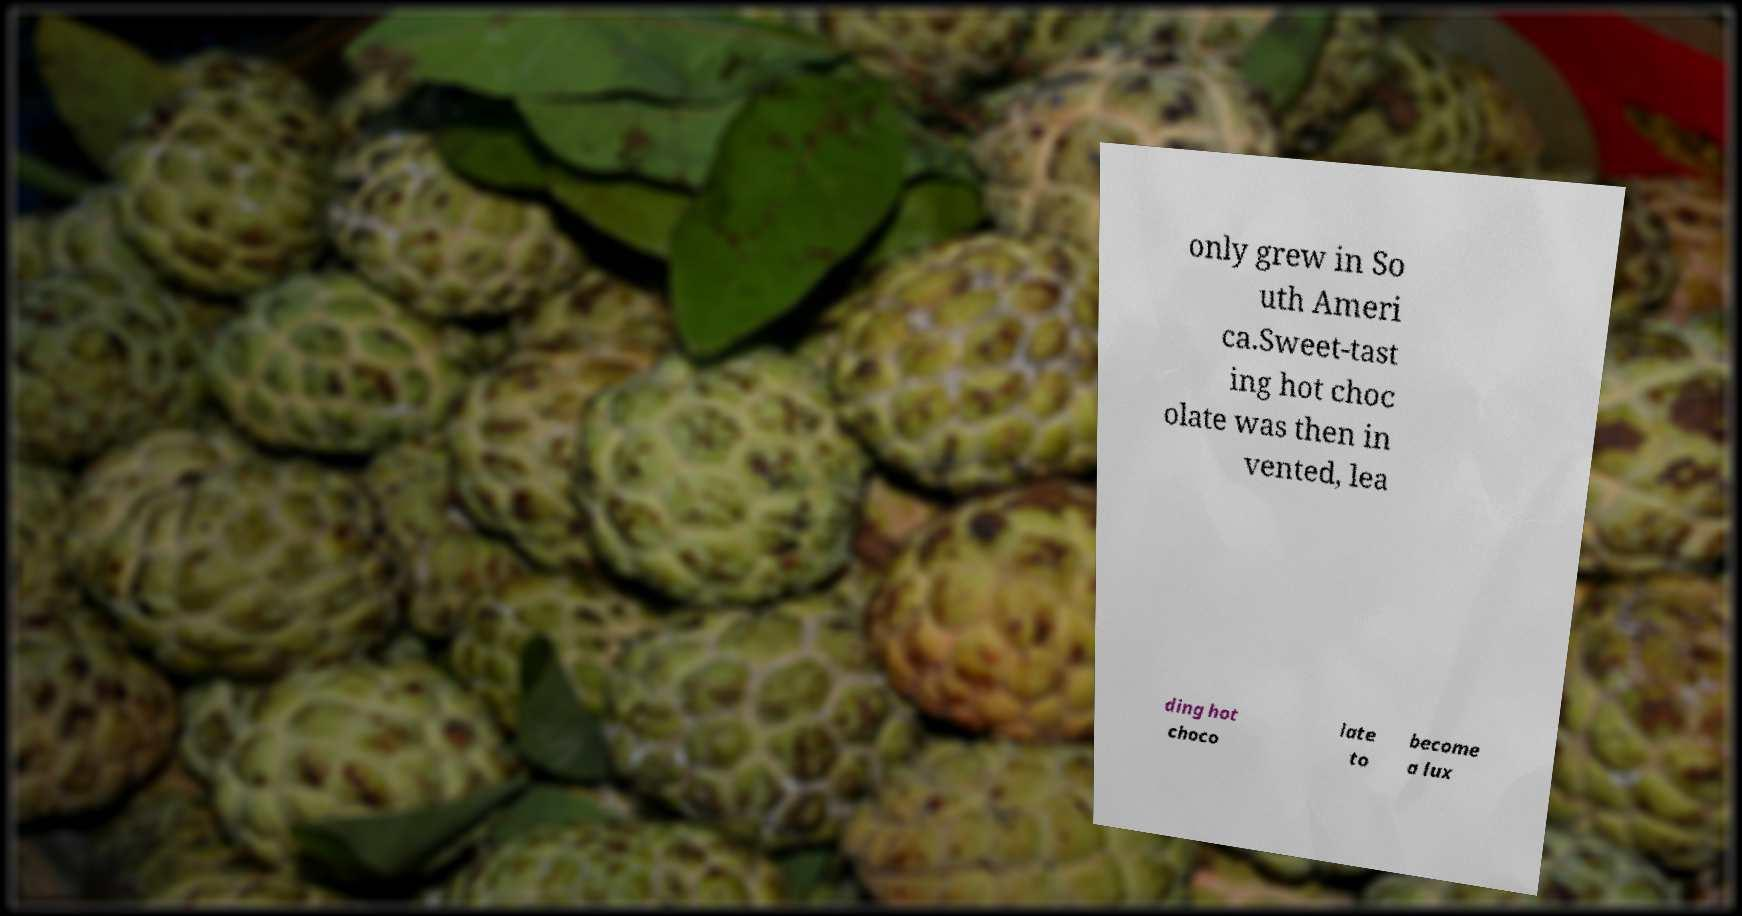For documentation purposes, I need the text within this image transcribed. Could you provide that? only grew in So uth Ameri ca.Sweet-tast ing hot choc olate was then in vented, lea ding hot choco late to become a lux 